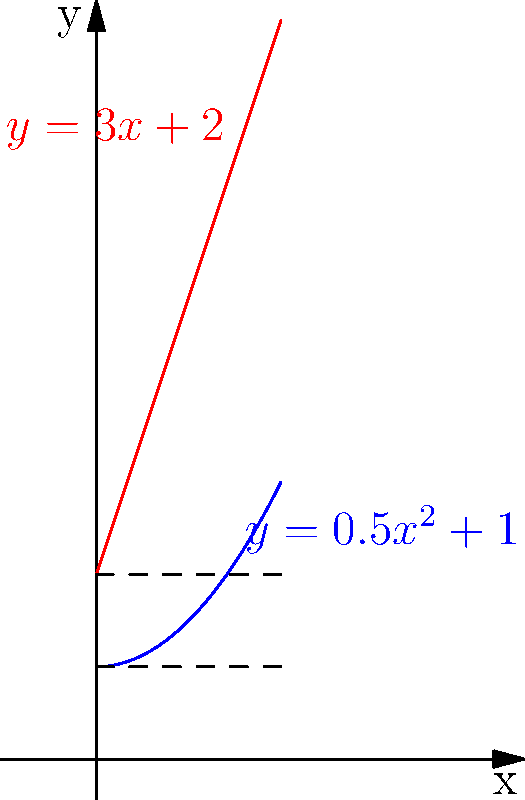As a successful solo artist, you've decided to design a unique speaker cabinet for your studio. The cabinet's cross-section is bounded by the curves $y=0.5x^2+1$ and $y=3x+2$, where $x$ and $y$ are measured in feet. If the cabinet is 4 feet deep, what is its volume in cubic feet? To find the volume of the speaker cabinet, we need to follow these steps:

1) First, we need to find the points of intersection of the two curves:
   $0.5x^2+1 = 3x+2$
   $0.5x^2-3x-1 = 0$
   
   Using the quadratic formula, we get:
   $x = \frac{3 \pm \sqrt{9+2(0.5)(1)}}{1} = 3 \pm \sqrt{10}$
   
   The points of intersection are $(3-\sqrt{10},0)$ and $(3+\sqrt{10},0)$

2) The volume can be found by rotating the area between the curves around the y-axis. We'll use the washer method:

   $V = \pi \int_a^b [R(y)^2 - r(y)^2] dy$

   Where $R(y)$ is the outer function and $r(y)$ is the inner function when solved for x.

3) Solving for x:
   From $y=0.5x^2+1$, we get $x = \sqrt{2(y-1)}$
   From $y=3x+2$, we get $x = \frac{y-2}{3}$

4) The limits of integration are from $y=1$ to $y=2$ (the y-coordinates of the intersection points)

5) Substituting into the volume formula:

   $V = 4\pi \int_1^2 [(\frac{y-2}{3})^2 - (2(y-1))^2] dy$

6) Simplifying:
   $V = 4\pi \int_1^2 [\frac{(y-2)^2}{9} - 2(y-1)] dy$

7) Integrating:
   $V = 4\pi [\frac{(y-2)^3}{27} - (y-1)^2]_1^2$

8) Evaluating the limits:
   $V = 4\pi [\frac{0^3}{27} - 1^2 - (\frac{-1^3}{27} - 0^2)]$
   $V = 4\pi [\frac{1}{27}]$
   $V = \frac{4\pi}{27}$ cubic feet
Answer: $\frac{4\pi}{27}$ cubic feet 